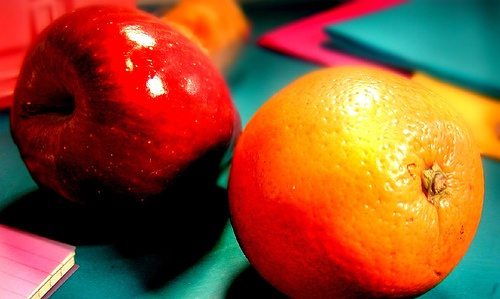Describe the objects in this image and their specific colors. I can see orange in red, orange, and gold tones, apple in red, black, and maroon tones, and book in red, salmon, lightpink, and khaki tones in this image. 